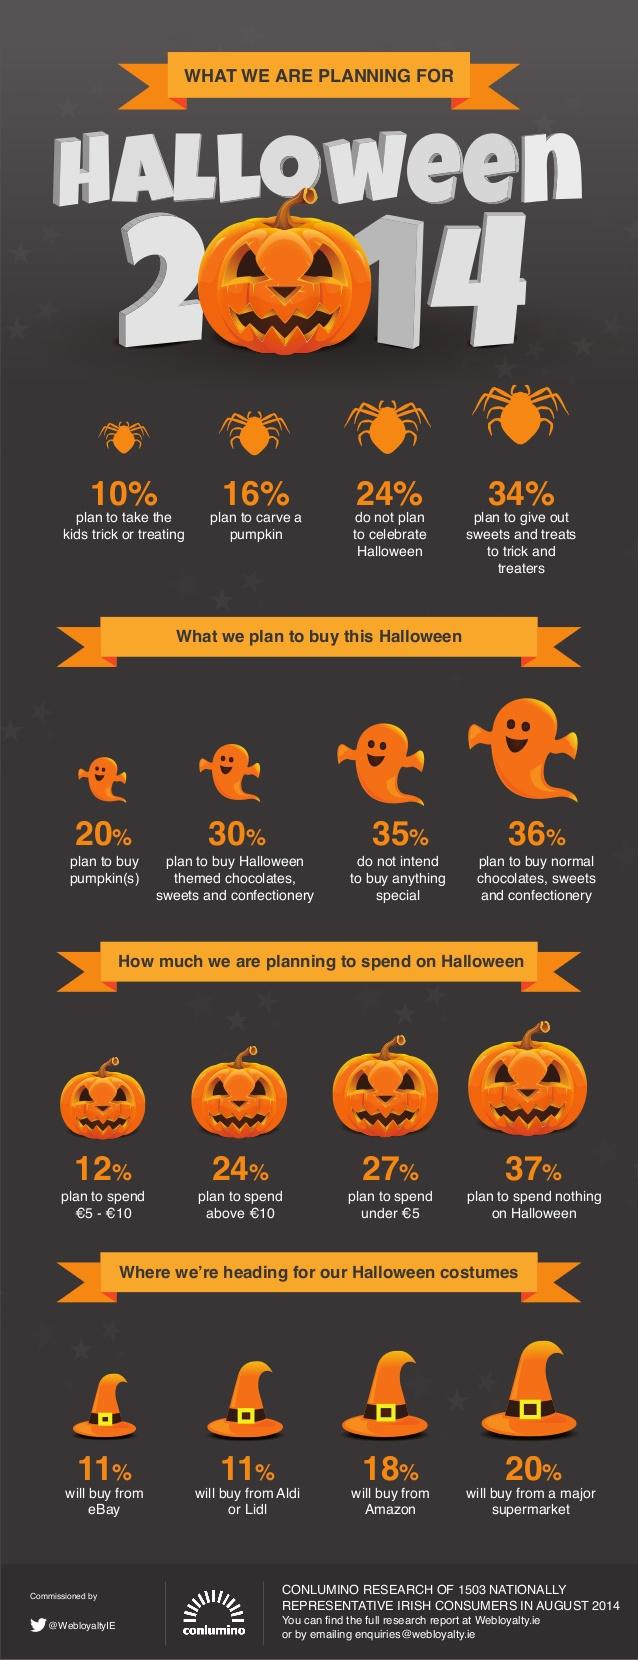Identify some key points in this picture. According to a recent survey, carving pumpkins is the third most popular activity that people plan to do for Halloween. According to the survey, 24% of people plan to spend more than 10 euros on Halloween. In 2014, 24% of people reported that they were not planning to celebrate Halloween. The most popular items that people plan to purchase are normal chocolates, sweets, and confectionary. It is estimated that approximately 10% of people plan to take their children trick or treating on Halloween. 